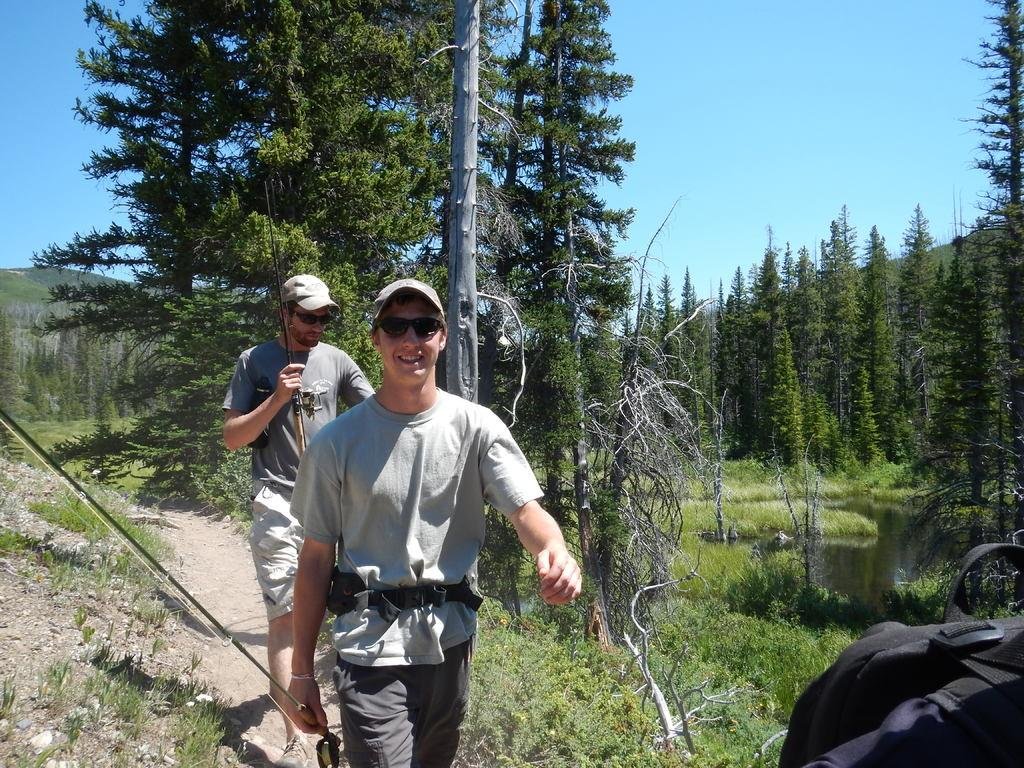How many people are in the image? There are two people in the image. What are the people doing in the image? The people are walking on land. What are the people holding in their hands? The people are holding sticks in their hands. What can be seen in the background of the image? There are trees, a mountain, and the sky visible in the background of the image. What type of furniture can be seen in the bedroom in the image? There is no bedroom present in the image; it features two people walking on land with sticks in their hands. What sound can be heard coming from the people in the image? The image does not provide any information about sounds or laughter; it only shows two people walking on land with sticks in their hands. 